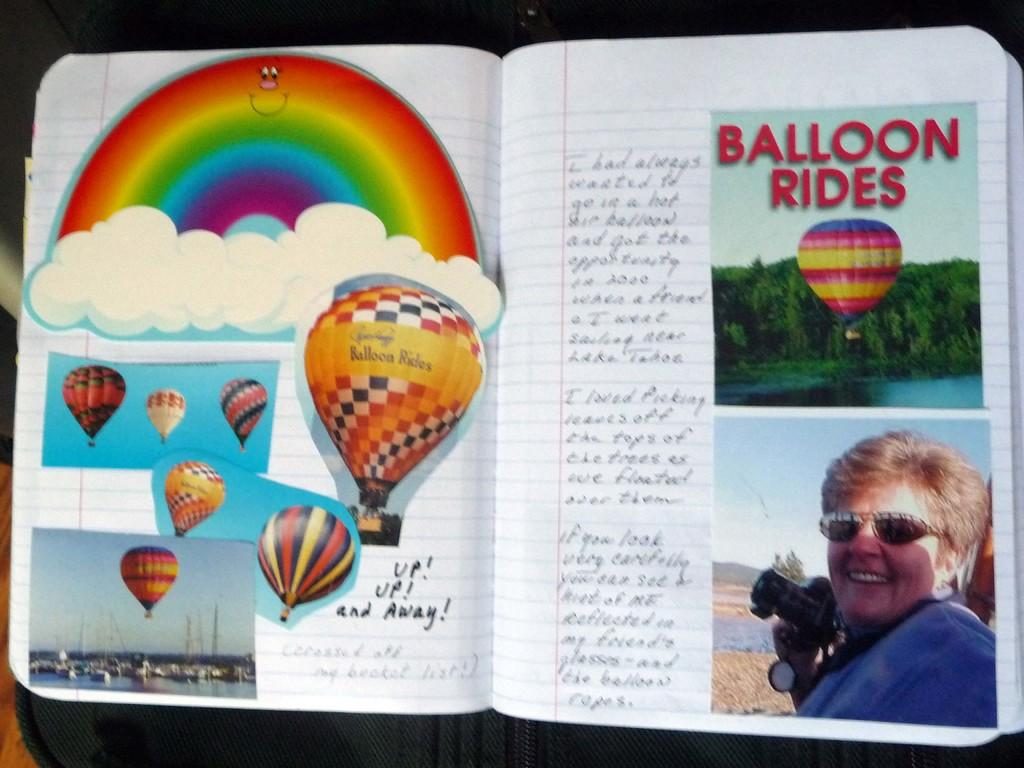What object is present in the image? There is a book in the image. What can be found on the pages of the book? The book has text and photos on it. What type of nerve is visible in the image? There is no nerve present in the image; it features a book with text and photos. What kind of plants can be seen growing in the image? There are no plants visible in the image; it features a book with text and photos. 